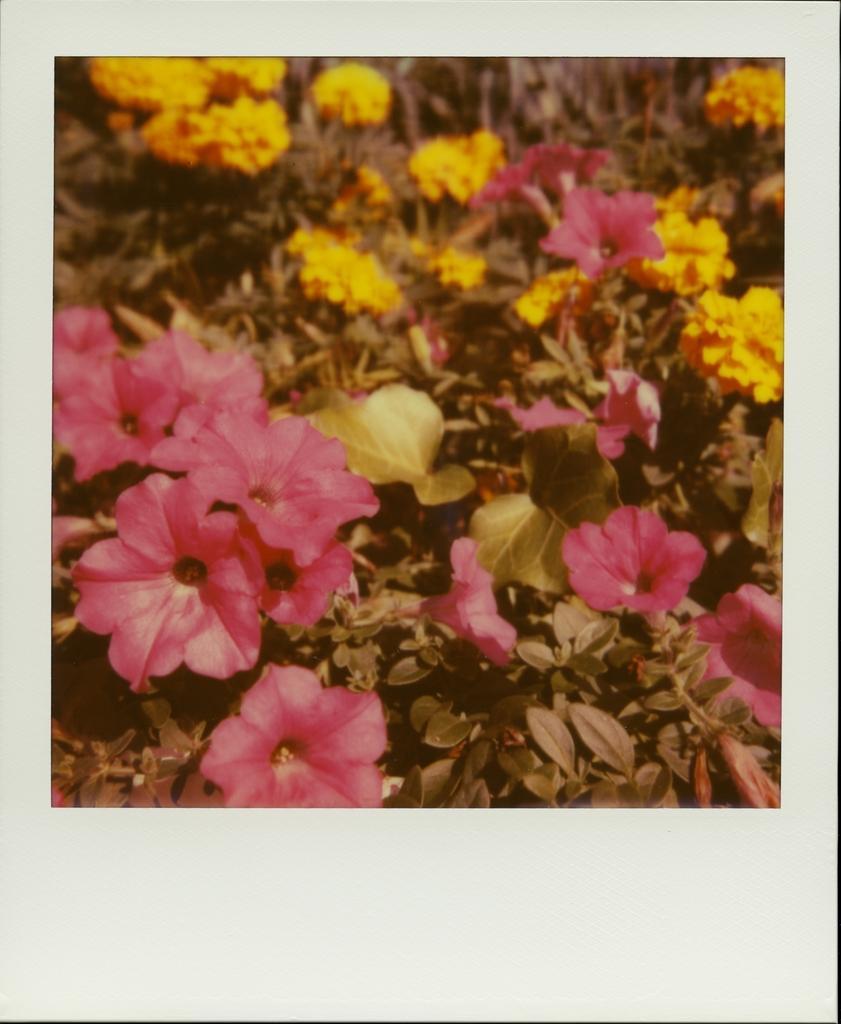Describe this image in one or two sentences. There is a photograph of pink and yellow flower plants. 